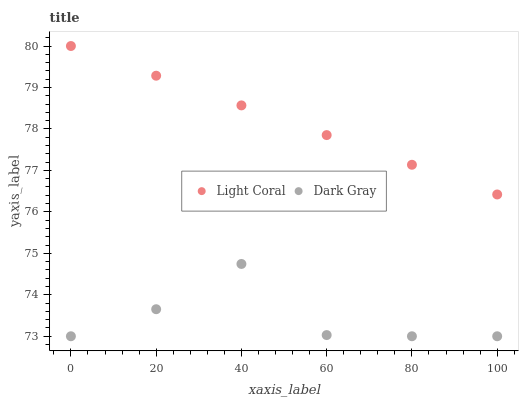Does Dark Gray have the minimum area under the curve?
Answer yes or no. Yes. Does Light Coral have the maximum area under the curve?
Answer yes or no. Yes. Does Dark Gray have the maximum area under the curve?
Answer yes or no. No. Is Light Coral the smoothest?
Answer yes or no. Yes. Is Dark Gray the roughest?
Answer yes or no. Yes. Is Dark Gray the smoothest?
Answer yes or no. No. Does Dark Gray have the lowest value?
Answer yes or no. Yes. Does Light Coral have the highest value?
Answer yes or no. Yes. Does Dark Gray have the highest value?
Answer yes or no. No. Is Dark Gray less than Light Coral?
Answer yes or no. Yes. Is Light Coral greater than Dark Gray?
Answer yes or no. Yes. Does Dark Gray intersect Light Coral?
Answer yes or no. No. 